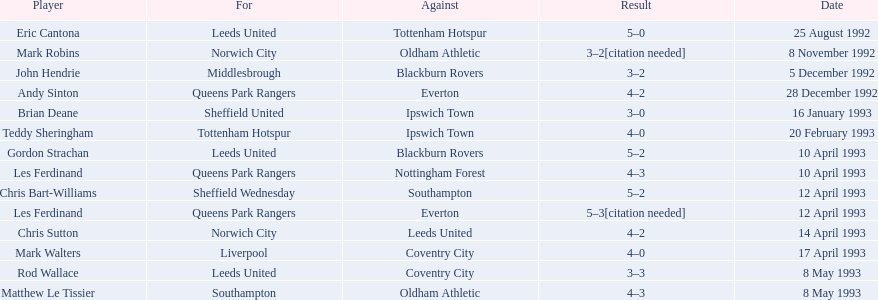What are the consequences? 5–0, 3–2[citation needed], 3–2, 4–2, 3–0, 4–0, 5–2, 4–3, 5–2, 5–3[citation needed], 4–2, 4–0, 3–3, 4–3. What consequence did mark robins experience? 3–2[citation needed]. Which other player experienced that consequence? John Hendrie. 